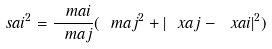<formula> <loc_0><loc_0><loc_500><loc_500>\ s a i ^ { 2 } = \frac { \ m a i } { \ m a j } ( \ m a j ^ { 2 } + | \ x a j - \ x a i | ^ { 2 } )</formula> 